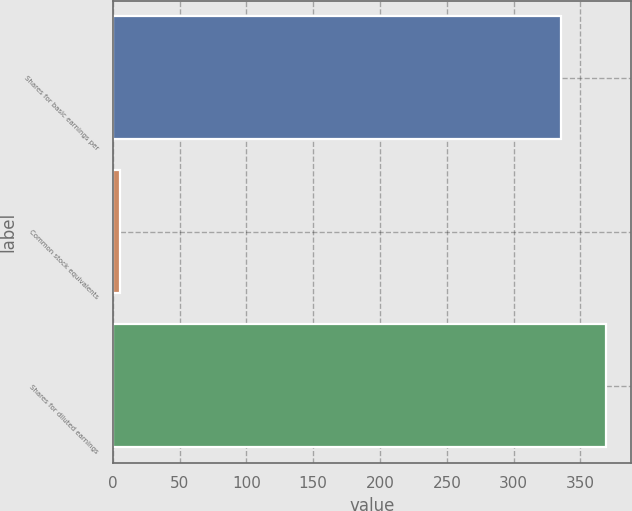Convert chart. <chart><loc_0><loc_0><loc_500><loc_500><bar_chart><fcel>Shares for basic earnings per<fcel>Common stock equivalents<fcel>Shares for diluted earnings<nl><fcel>335.5<fcel>5.4<fcel>369.05<nl></chart> 